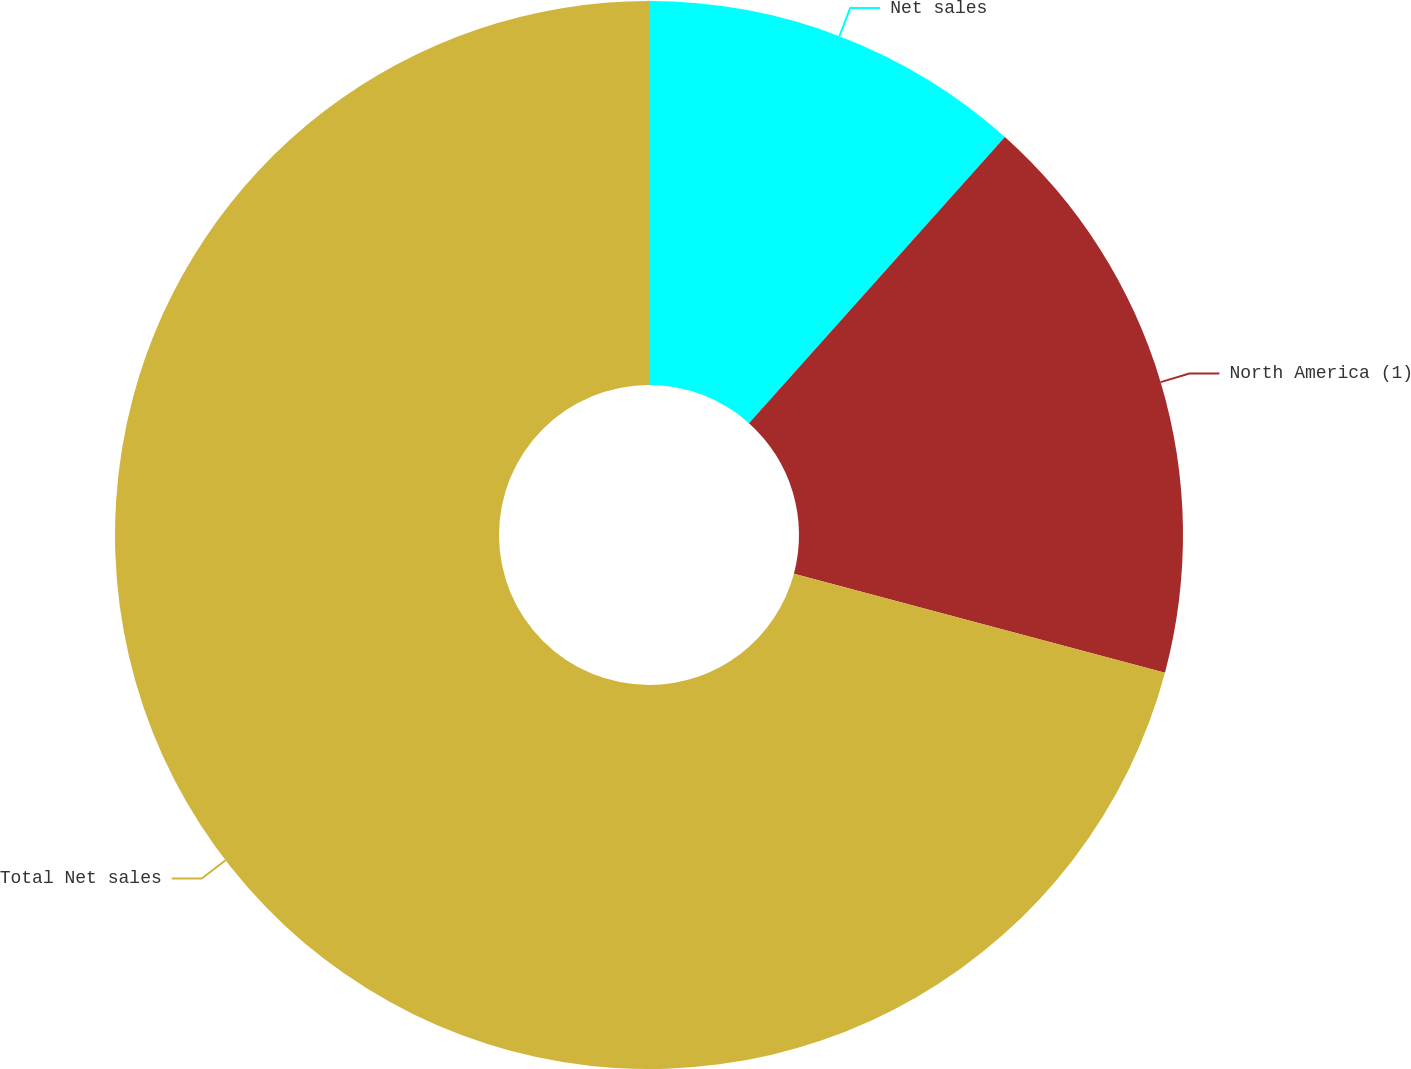Convert chart. <chart><loc_0><loc_0><loc_500><loc_500><pie_chart><fcel>Net sales<fcel>North America (1)<fcel>Total Net sales<nl><fcel>11.61%<fcel>17.54%<fcel>70.85%<nl></chart> 